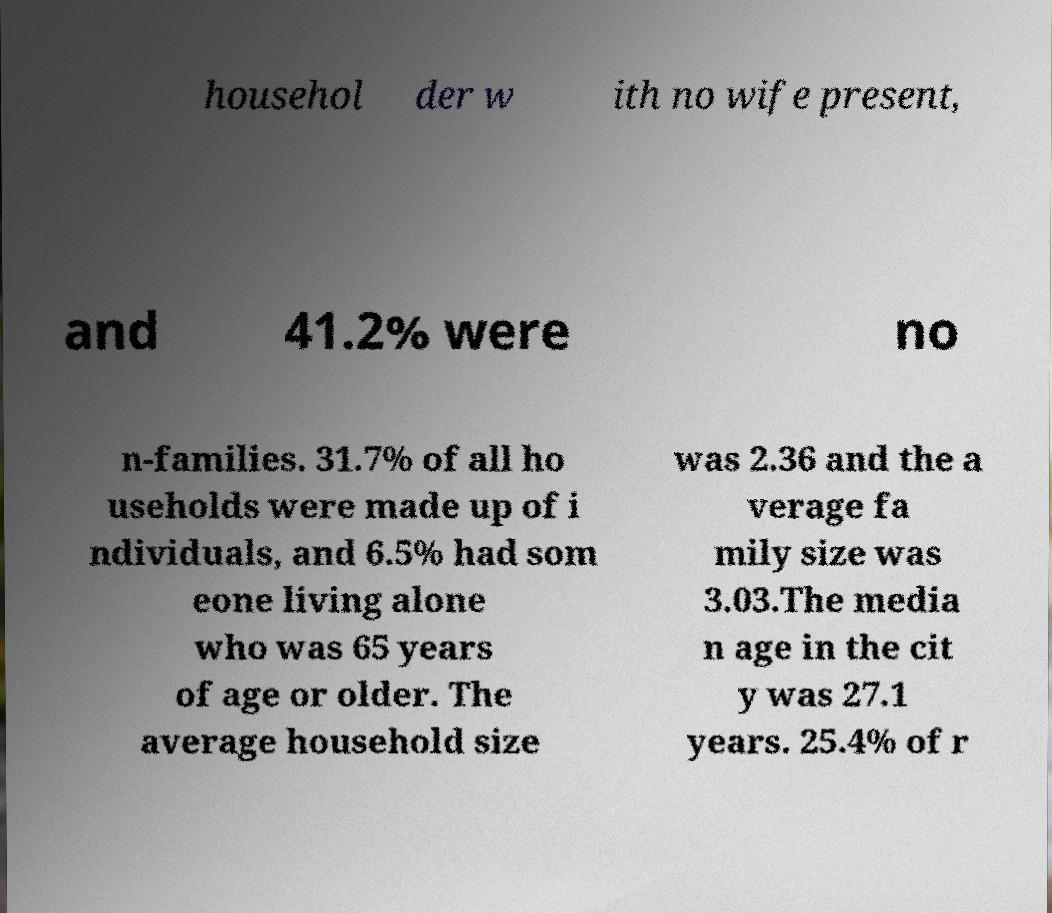I need the written content from this picture converted into text. Can you do that? househol der w ith no wife present, and 41.2% were no n-families. 31.7% of all ho useholds were made up of i ndividuals, and 6.5% had som eone living alone who was 65 years of age or older. The average household size was 2.36 and the a verage fa mily size was 3.03.The media n age in the cit y was 27.1 years. 25.4% of r 